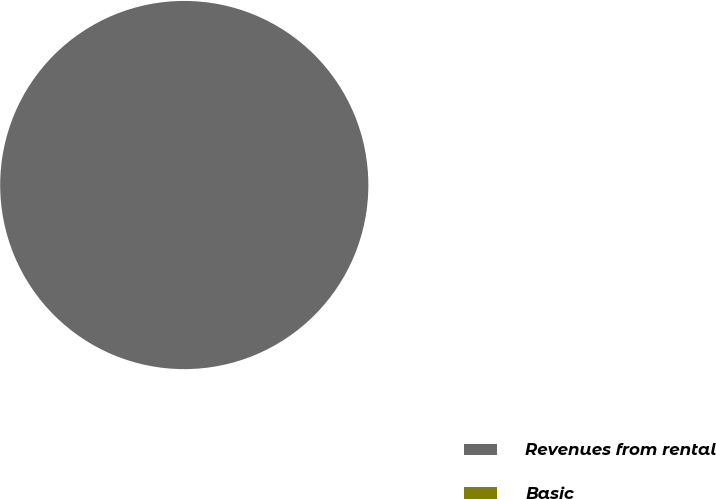Convert chart to OTSL. <chart><loc_0><loc_0><loc_500><loc_500><pie_chart><fcel>Revenues from rental<fcel>Basic<nl><fcel>100.0%<fcel>0.0%<nl></chart> 